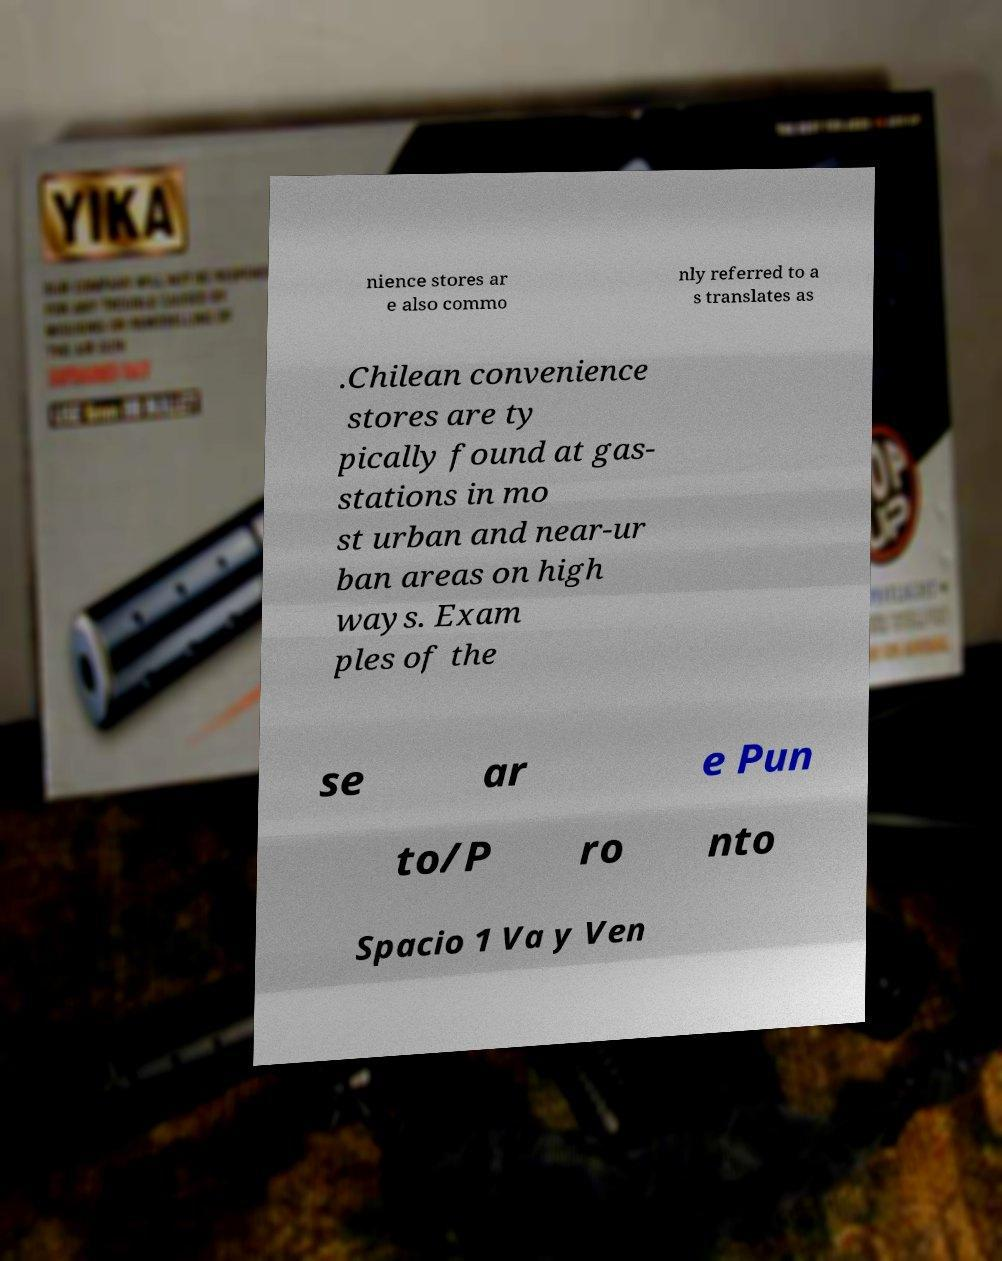Please read and relay the text visible in this image. What does it say? nience stores ar e also commo nly referred to a s translates as .Chilean convenience stores are ty pically found at gas- stations in mo st urban and near-ur ban areas on high ways. Exam ples of the se ar e Pun to/P ro nto Spacio 1 Va y Ven 